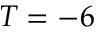<formula> <loc_0><loc_0><loc_500><loc_500>T = - 6</formula> 